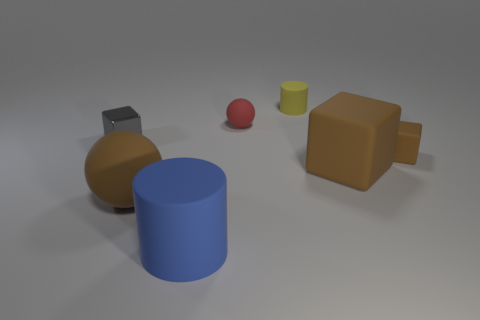Are the tiny brown cube and the sphere that is behind the big brown matte block made of the same material?
Offer a terse response. Yes. How many things are tiny red spheres or brown balls?
Provide a succinct answer. 2. There is a big thing that is the same color as the big matte sphere; what is it made of?
Provide a short and direct response. Rubber. Are there any small yellow things that have the same shape as the small gray thing?
Offer a very short reply. No. What number of red matte objects are behind the small yellow object?
Offer a terse response. 0. There is a small cube behind the small block right of the big blue cylinder; what is it made of?
Make the answer very short. Metal. What material is the brown sphere that is the same size as the blue cylinder?
Your answer should be compact. Rubber. Are there any yellow rubber things of the same size as the blue rubber thing?
Provide a short and direct response. No. There is a tiny rubber object in front of the metallic cube; what is its color?
Ensure brevity in your answer.  Brown. Are there any matte balls in front of the cylinder that is in front of the small red rubber object?
Offer a terse response. No. 